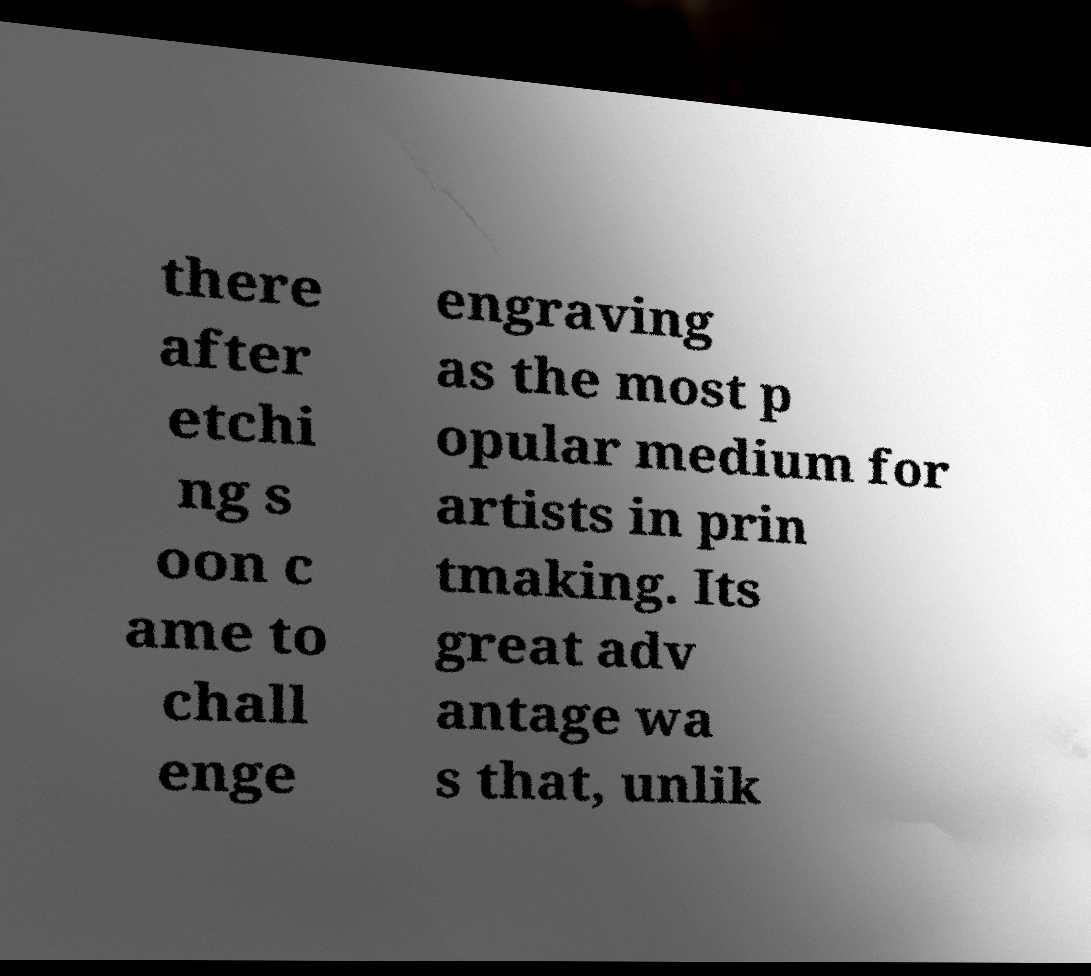Please identify and transcribe the text found in this image. there after etchi ng s oon c ame to chall enge engraving as the most p opular medium for artists in prin tmaking. Its great adv antage wa s that, unlik 